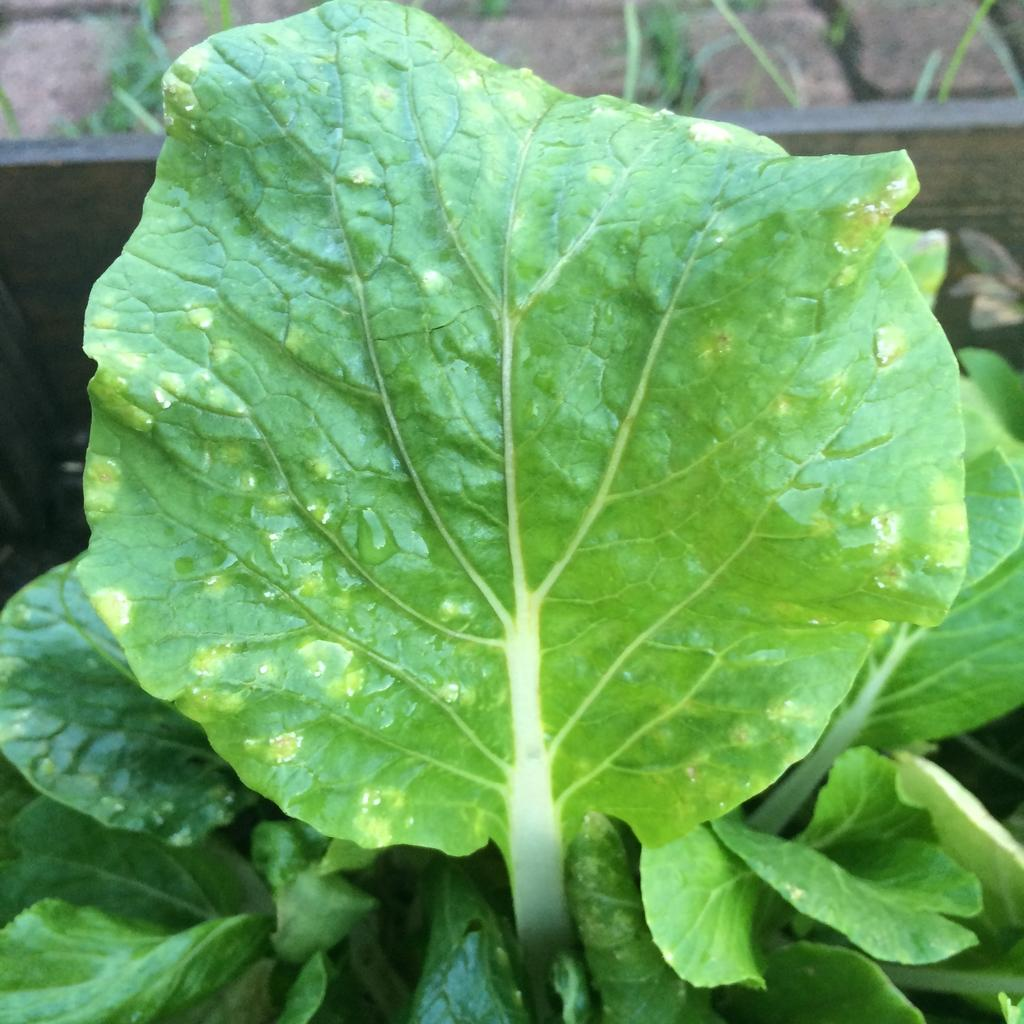What is the main subject of the image? The main subject of the image is a plant. What specific features can be observed on the plant? The plant has leaves. Can you describe the background of the image? The background of the image is blurred. How many apples are hanging from the plant in the image? There are no apples present in the image; it only features a plant with leaves. What force is being applied to the plant in the image? There is no force being applied to the plant in the image; it is stationary in its natural environment. 